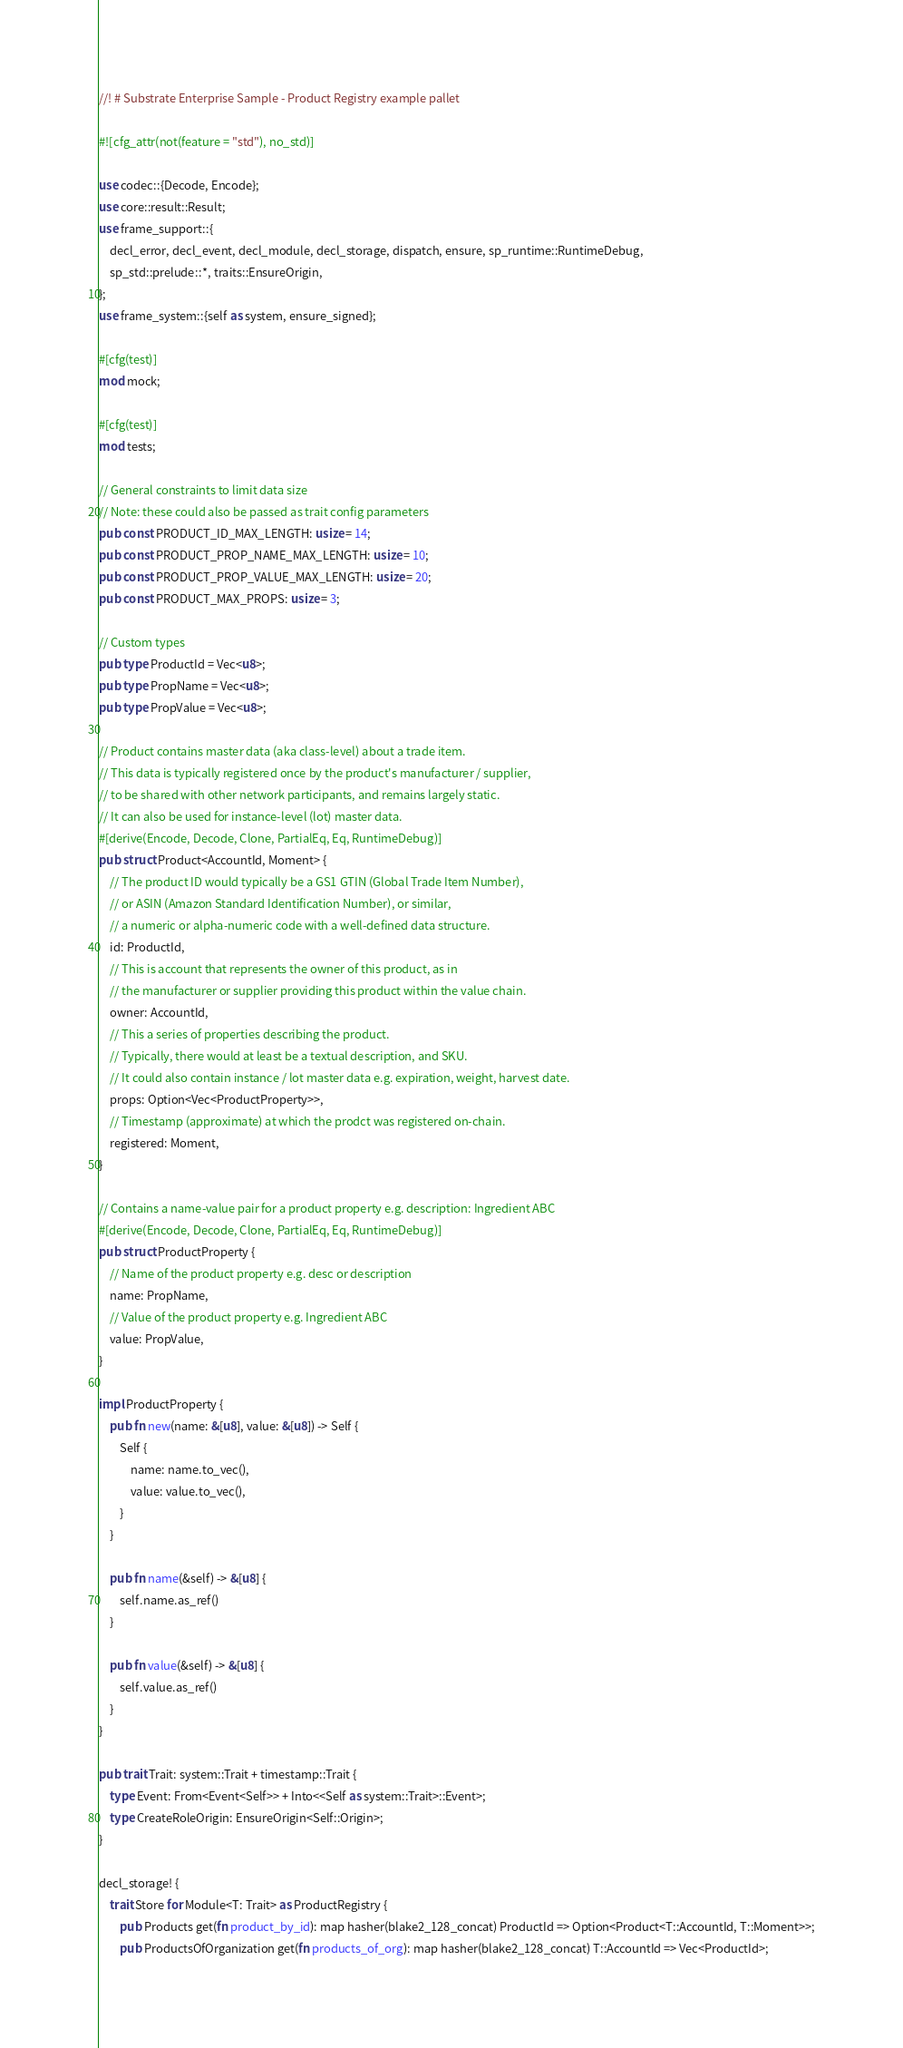<code> <loc_0><loc_0><loc_500><loc_500><_Rust_>//! # Substrate Enterprise Sample - Product Registry example pallet

#![cfg_attr(not(feature = "std"), no_std)]

use codec::{Decode, Encode};
use core::result::Result;
use frame_support::{
    decl_error, decl_event, decl_module, decl_storage, dispatch, ensure, sp_runtime::RuntimeDebug,
    sp_std::prelude::*, traits::EnsureOrigin,
};
use frame_system::{self as system, ensure_signed};

#[cfg(test)]
mod mock;

#[cfg(test)]
mod tests;

// General constraints to limit data size
// Note: these could also be passed as trait config parameters
pub const PRODUCT_ID_MAX_LENGTH: usize = 14;
pub const PRODUCT_PROP_NAME_MAX_LENGTH: usize = 10;
pub const PRODUCT_PROP_VALUE_MAX_LENGTH: usize = 20;
pub const PRODUCT_MAX_PROPS: usize = 3;

// Custom types
pub type ProductId = Vec<u8>;
pub type PropName = Vec<u8>;
pub type PropValue = Vec<u8>;

// Product contains master data (aka class-level) about a trade item.
// This data is typically registered once by the product's manufacturer / supplier,
// to be shared with other network participants, and remains largely static.
// It can also be used for instance-level (lot) master data.
#[derive(Encode, Decode, Clone, PartialEq, Eq, RuntimeDebug)]
pub struct Product<AccountId, Moment> {
    // The product ID would typically be a GS1 GTIN (Global Trade Item Number),
    // or ASIN (Amazon Standard Identification Number), or similar,
    // a numeric or alpha-numeric code with a well-defined data structure.
    id: ProductId,
    // This is account that represents the owner of this product, as in
    // the manufacturer or supplier providing this product within the value chain.
    owner: AccountId,
    // This a series of properties describing the product.
    // Typically, there would at least be a textual description, and SKU.
    // It could also contain instance / lot master data e.g. expiration, weight, harvest date.
    props: Option<Vec<ProductProperty>>,
    // Timestamp (approximate) at which the prodct was registered on-chain.
    registered: Moment,
}

// Contains a name-value pair for a product property e.g. description: Ingredient ABC
#[derive(Encode, Decode, Clone, PartialEq, Eq, RuntimeDebug)]
pub struct ProductProperty {
    // Name of the product property e.g. desc or description
    name: PropName,
    // Value of the product property e.g. Ingredient ABC
    value: PropValue,
}

impl ProductProperty {
    pub fn new(name: &[u8], value: &[u8]) -> Self {
        Self {
            name: name.to_vec(),
            value: value.to_vec(),
        }
    }

    pub fn name(&self) -> &[u8] {
        self.name.as_ref()
    }

    pub fn value(&self) -> &[u8] {
        self.value.as_ref()
    }
}

pub trait Trait: system::Trait + timestamp::Trait {
    type Event: From<Event<Self>> + Into<<Self as system::Trait>::Event>;
    type CreateRoleOrigin: EnsureOrigin<Self::Origin>;
}

decl_storage! {
    trait Store for Module<T: Trait> as ProductRegistry {
        pub Products get(fn product_by_id): map hasher(blake2_128_concat) ProductId => Option<Product<T::AccountId, T::Moment>>;
        pub ProductsOfOrganization get(fn products_of_org): map hasher(blake2_128_concat) T::AccountId => Vec<ProductId>;</code> 